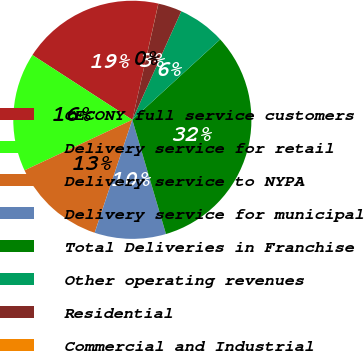Convert chart. <chart><loc_0><loc_0><loc_500><loc_500><pie_chart><fcel>CECONY full service customers<fcel>Delivery service for retail<fcel>Delivery service to NYPA<fcel>Delivery service for municipal<fcel>Total Deliveries in Franchise<fcel>Other operating revenues<fcel>Residential<fcel>Commercial and Industrial<nl><fcel>19.35%<fcel>16.13%<fcel>12.9%<fcel>9.68%<fcel>32.24%<fcel>6.46%<fcel>3.23%<fcel>0.01%<nl></chart> 